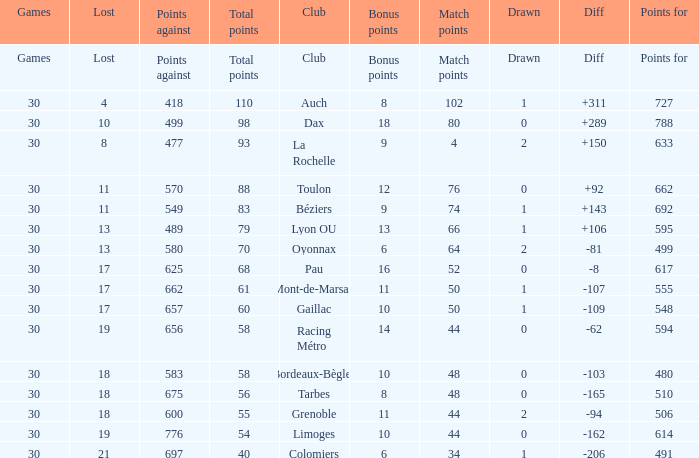What is the amount of match points for a club that lost 18 and has 11 bonus points? 44.0. Could you help me parse every detail presented in this table? {'header': ['Games', 'Lost', 'Points against', 'Total points', 'Club', 'Bonus points', 'Match points', 'Drawn', 'Diff', 'Points for'], 'rows': [['Games', 'Lost', 'Points against', 'Total points', 'Club', 'Bonus points', 'Match points', 'Drawn', 'Diff', 'Points for'], ['30', '4', '418', '110', 'Auch', '8', '102', '1', '+311', '727'], ['30', '10', '499', '98', 'Dax', '18', '80', '0', '+289', '788'], ['30', '8', '477', '93', 'La Rochelle', '9', '4', '2', '+150', '633'], ['30', '11', '570', '88', 'Toulon', '12', '76', '0', '+92', '662'], ['30', '11', '549', '83', 'Béziers', '9', '74', '1', '+143', '692'], ['30', '13', '489', '79', 'Lyon OU', '13', '66', '1', '+106', '595'], ['30', '13', '580', '70', 'Oyonnax', '6', '64', '2', '-81', '499'], ['30', '17', '625', '68', 'Pau', '16', '52', '0', '-8', '617'], ['30', '17', '662', '61', 'Mont-de-Marsan', '11', '50', '1', '-107', '555'], ['30', '17', '657', '60', 'Gaillac', '10', '50', '1', '-109', '548'], ['30', '19', '656', '58', 'Racing Métro', '14', '44', '0', '-62', '594'], ['30', '18', '583', '58', 'Bordeaux-Bègles', '10', '48', '0', '-103', '480'], ['30', '18', '675', '56', 'Tarbes', '8', '48', '0', '-165', '510'], ['30', '18', '600', '55', 'Grenoble', '11', '44', '2', '-94', '506'], ['30', '19', '776', '54', 'Limoges', '10', '44', '0', '-162', '614'], ['30', '21', '697', '40', 'Colomiers', '6', '34', '1', '-206', '491']]} 